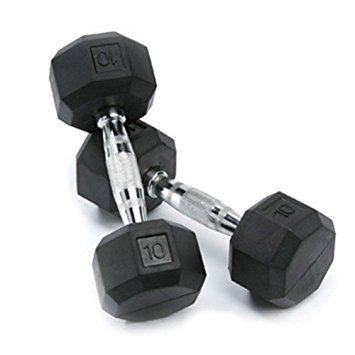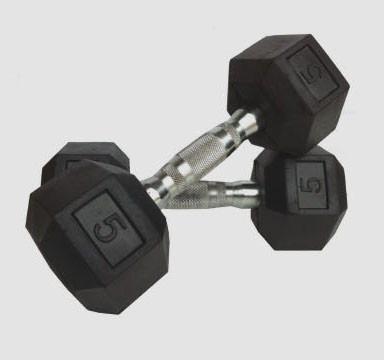The first image is the image on the left, the second image is the image on the right. Analyze the images presented: Is the assertion "Each image shows one overlapping pair of dumbbells, but the left image shows the overlapping dumbbell almost vertical, and the right image shows the overlapping dumbbell more diagonal." valid? Answer yes or no. Yes. The first image is the image on the left, the second image is the image on the right. Analyze the images presented: Is the assertion "The left and right image contains the same number of dumbells." valid? Answer yes or no. Yes. 